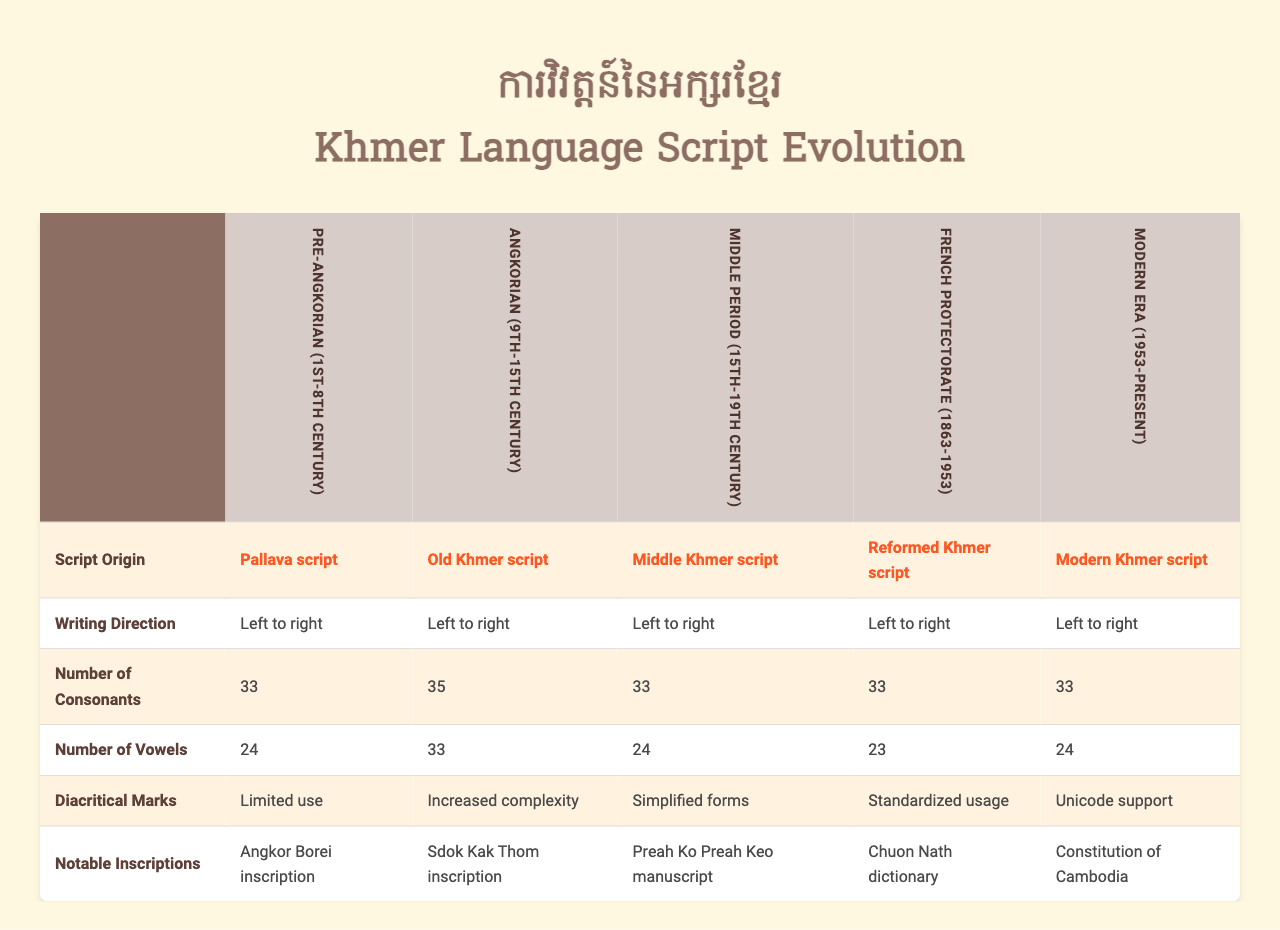What is the origin of the script used during the Middle Period? According to the table, the Middle Period uses the Middle Khmer script, which originates from the Old Khmer script.
Answer: Middle Khmer script How many consonants are present in the Modern Khmer script? The table indicates that the Modern Khmer script has 33 consonants.
Answer: 33 Did the number of vowels increase from the French Protectorate to the Modern Era? The French Protectorate had 23 vowels, while the Modern Era has 24 vowels, indicating an increase of 1.
Answer: Yes Which period saw the highest number of vowels recorded? By comparing the number of vowels across periods, Old Khmer script during the Angkorian period had the highest count at 33 vowels.
Answer: Angkorian period Is the writing direction the same across all periods? The table shows that the writing direction for all periods is "Left to right." Thus, the writing direction is consistent.
Answer: Yes What notable inscription is associated with the Pre-Angkorian period? Referring to the data, the notable inscription for the Pre-Angkorian period is the Angkor Borei inscription.
Answer: Angkor Borei inscription How many diacritical marks were used in the Old Khmer script compared to the Reformed Khmer script? Old Khmer script had "Increased complexity" in its diacritical marks, while the Reformed Khmer script had "Standardized usage." Both suggest a difference in approach rather than a quantitative comparison.
Answer: Not directly comparable Which script period had the least number of vowels, and how many were there? The Middle Period listed 24 vowels, while both the Pre-Angkorian and the Modern Era had 24 vowels. Therefore, there's no single least count—three periods share this count.
Answer: None, tied at 24 What was the evolution trend of consonants through these periods? The number of consonants remained constant at 33 for most periods but varied only in the number of vowels across periods. Thus, consonants did not show any trending increase or decrease.
Answer: Constant at 33 Can we conclude that the Khmer script became simpler over time? Considering the characteristics, there was simplification in diacritical marks and forms, suggesting a trend towards simplification from Old Khmer to Reformed Khmer script.
Answer: Yes, it simplified over time 